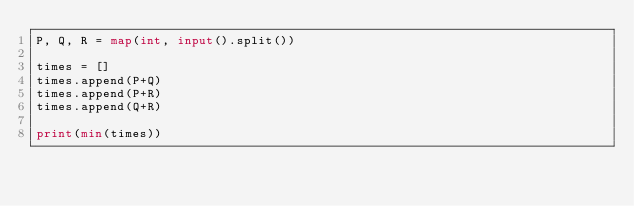<code> <loc_0><loc_0><loc_500><loc_500><_Python_>P, Q, R = map(int, input().split())

times = []
times.append(P+Q)
times.append(P+R)
times.append(Q+R)

print(min(times))</code> 